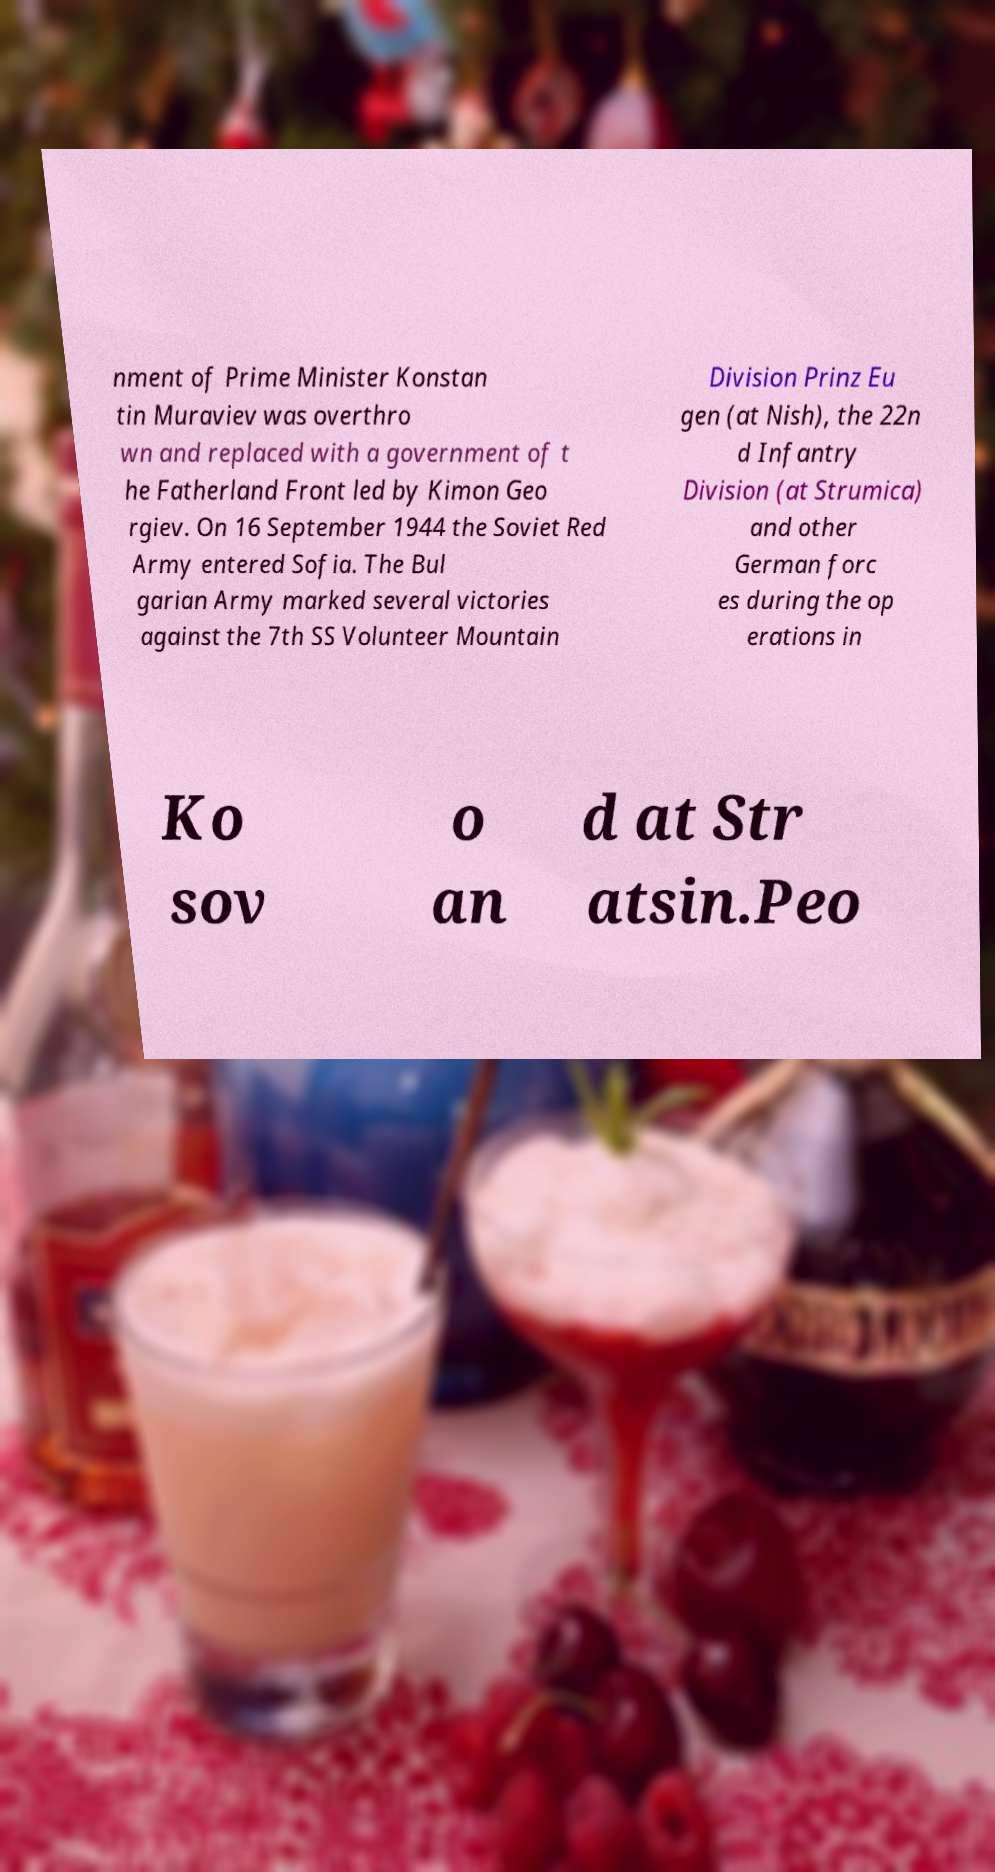I need the written content from this picture converted into text. Can you do that? nment of Prime Minister Konstan tin Muraviev was overthro wn and replaced with a government of t he Fatherland Front led by Kimon Geo rgiev. On 16 September 1944 the Soviet Red Army entered Sofia. The Bul garian Army marked several victories against the 7th SS Volunteer Mountain Division Prinz Eu gen (at Nish), the 22n d Infantry Division (at Strumica) and other German forc es during the op erations in Ko sov o an d at Str atsin.Peo 